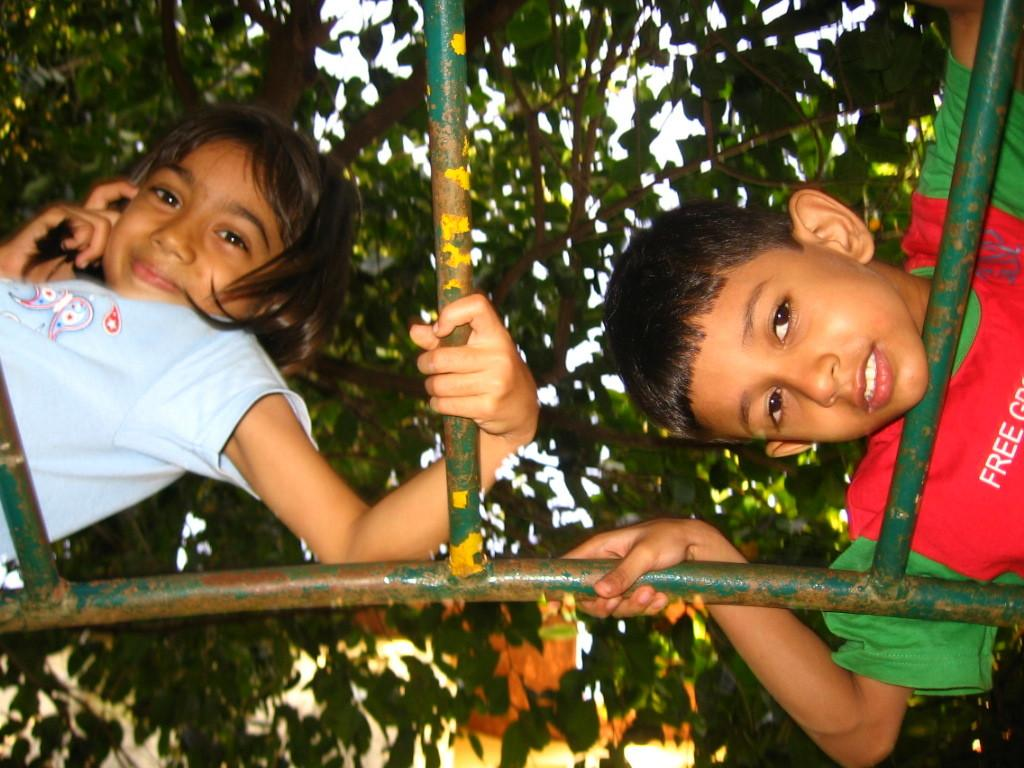How many people are in the image? There are two people in the image, a boy and a girl. What are the boy and girl wearing? The boy is wearing a red and green color jacket, and the girl is wearing a blue color t-t-shirt. What can be seen in the background of the image? There is a tree in the background of the image. What type of bread is the boy eating in the image? There is no bread present in the image; the boy is not eating anything. 